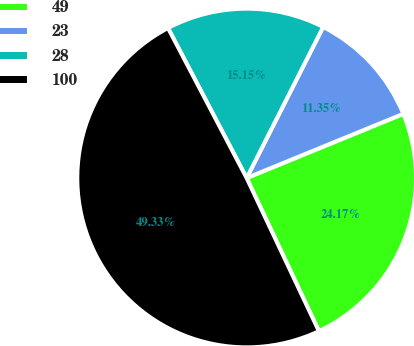Convert chart to OTSL. <chart><loc_0><loc_0><loc_500><loc_500><pie_chart><fcel>49<fcel>23<fcel>28<fcel>100<nl><fcel>24.17%<fcel>11.35%<fcel>15.15%<fcel>49.33%<nl></chart> 